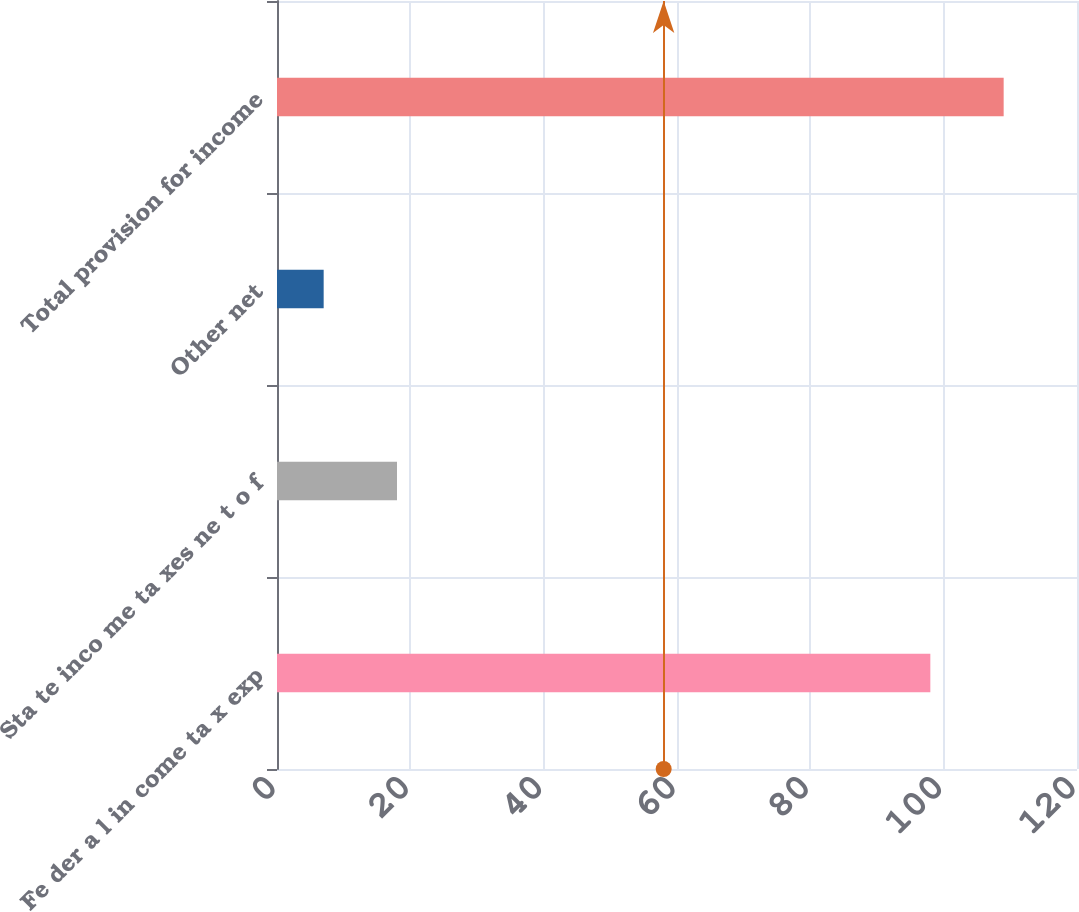<chart> <loc_0><loc_0><loc_500><loc_500><bar_chart><fcel>Fe der a l in come ta x exp<fcel>Sta te inco me ta xes ne t o f<fcel>Other net<fcel>Total provision for income<nl><fcel>98<fcel>18<fcel>7<fcel>109<nl></chart> 